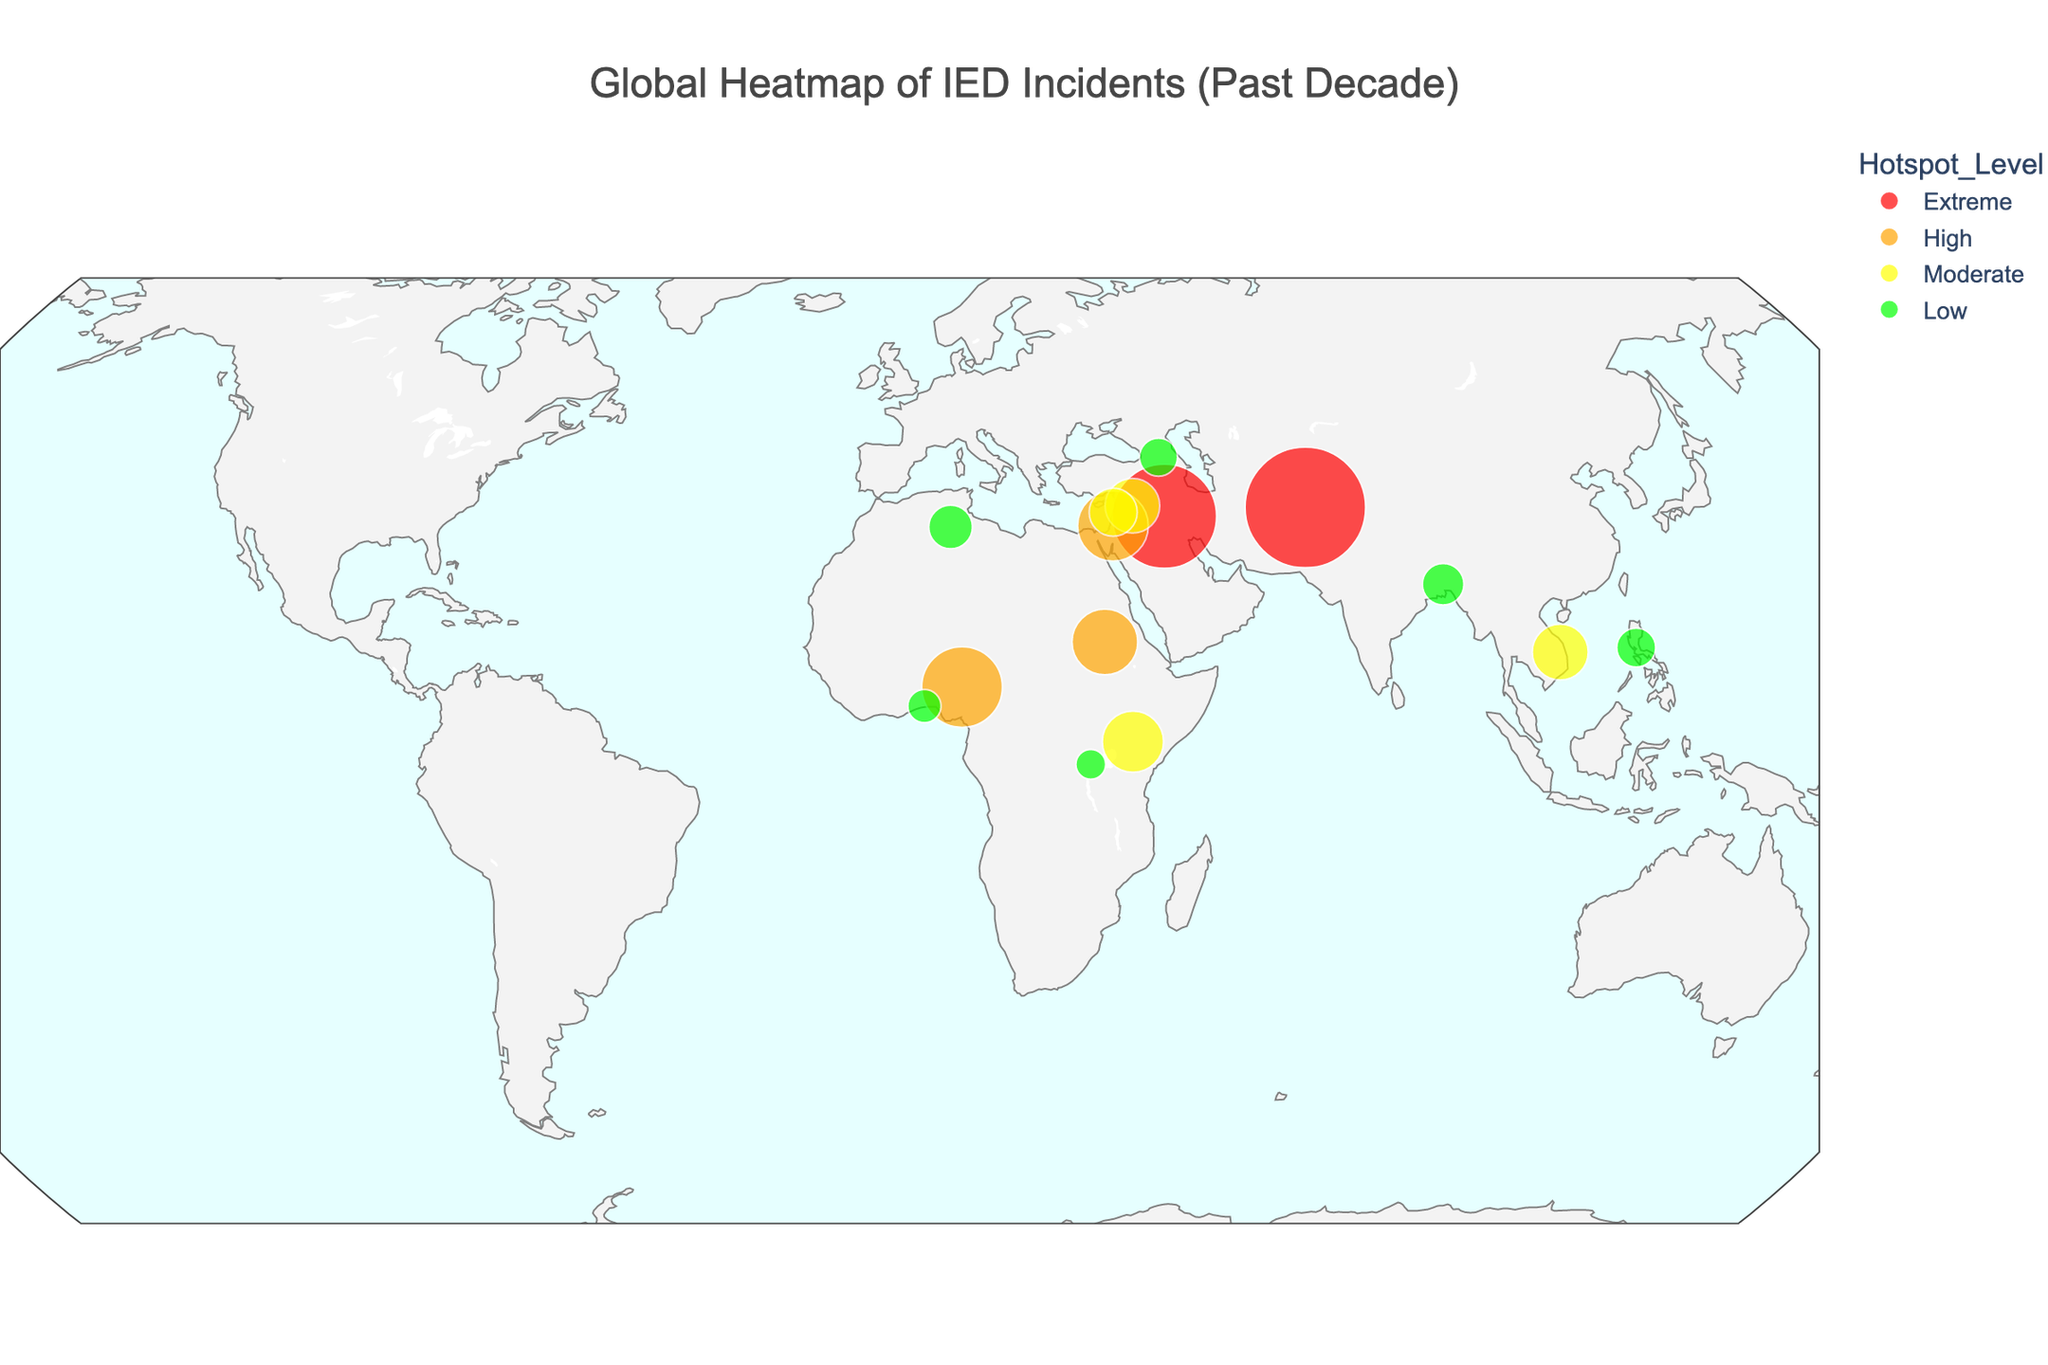What is the title of the plot? The title of the plot is given at the top, which helps us understand the main focus of the visual representation.
Answer: Global Heatmap of IED Incidents (Past Decade) Which country has the highest number of IED incidents? By looking at the size of the bubbles and the hover information from the plot, we can identify the country with the largest bubble under the "Extreme" hotspot level.
Answer: Afghanistan How many countries are classified under the "High" hotspot level? The "High" hotspot level is represented by orange bubbles, and counting these bubbles on the plot will give us the answer.
Answer: 3 Which countries fall under the "Low" hotspot level? Look for green bubbles indicating the "Low" hotspot level and note the corresponding countries.
Answer: Morocco, Bangladesh, Philippines, Georgia, Benin, Rwanda How many IED incidents occurred in Iraq? Hovering over the bubble in Iraq, as indicated by the latitude and longitude, will show us the exact number of IED incidents.
Answer: 2154 What is the combined number of IED incidents in Kenya and Vietnam? Sum the IED incidents in Kenya (743) and Vietnam (621) to get the total.
Answer: 1364 Which country has a greater number of IED incidents: Nigeria or Sudan? Compare the number of incidents in Nigeria (1289) with those in Sudan (856) based on the hover information from their respective bubbles.
Answer: Nigeria What is the average number of IED incidents for the countries under the "Extreme" hotspot level? Add the number of incidents in Afghanistan (2876) and Iraq (2154) and then divide by the number of countries (2). (2876 + 2154) / 2 = 2515
Answer: 2515 What is the difference between the number of IED incidents in West Bank and Syria? Subtract the number of incidents in Syria (589) from those in West Bank (987). 987 - 589 = 398
Answer: 398 How does the hotspot level correlate with the size of the bubbles? By examining the plot, note how the size of each bubble increases with the number of IED incidents, indicating that a higher hotspot level is associated with larger bubbles.
Answer: Larger bubbles for higher hotspot levels 